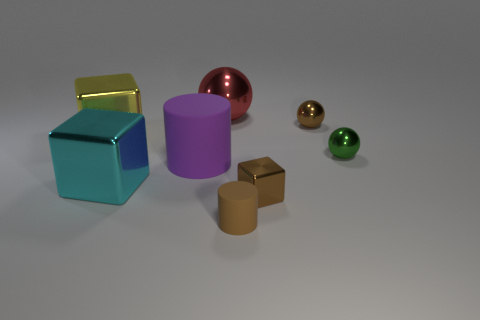What number of other objects are the same size as the red shiny thing?
Offer a terse response. 3. What is the shape of the rubber object to the right of the big red thing?
Provide a short and direct response. Cylinder. Is the material of the big cylinder the same as the small brown sphere?
Your answer should be very brief. No. There is a big cyan object that is the same shape as the big yellow metal thing; what material is it?
Provide a short and direct response. Metal. Are there fewer brown shiny things in front of the tiny metal cube than large red shiny objects?
Offer a terse response. Yes. What number of large yellow things are to the right of the small brown cube?
Provide a short and direct response. 0. There is a brown metallic object that is to the left of the small brown ball; is it the same shape as the brown thing behind the small brown metallic block?
Ensure brevity in your answer.  No. The shiny thing that is both right of the cyan cube and on the left side of the small brown matte thing has what shape?
Provide a succinct answer. Sphere. There is a brown cylinder that is made of the same material as the big purple object; what size is it?
Provide a short and direct response. Small. Is the number of red matte things less than the number of purple cylinders?
Your answer should be very brief. Yes. 